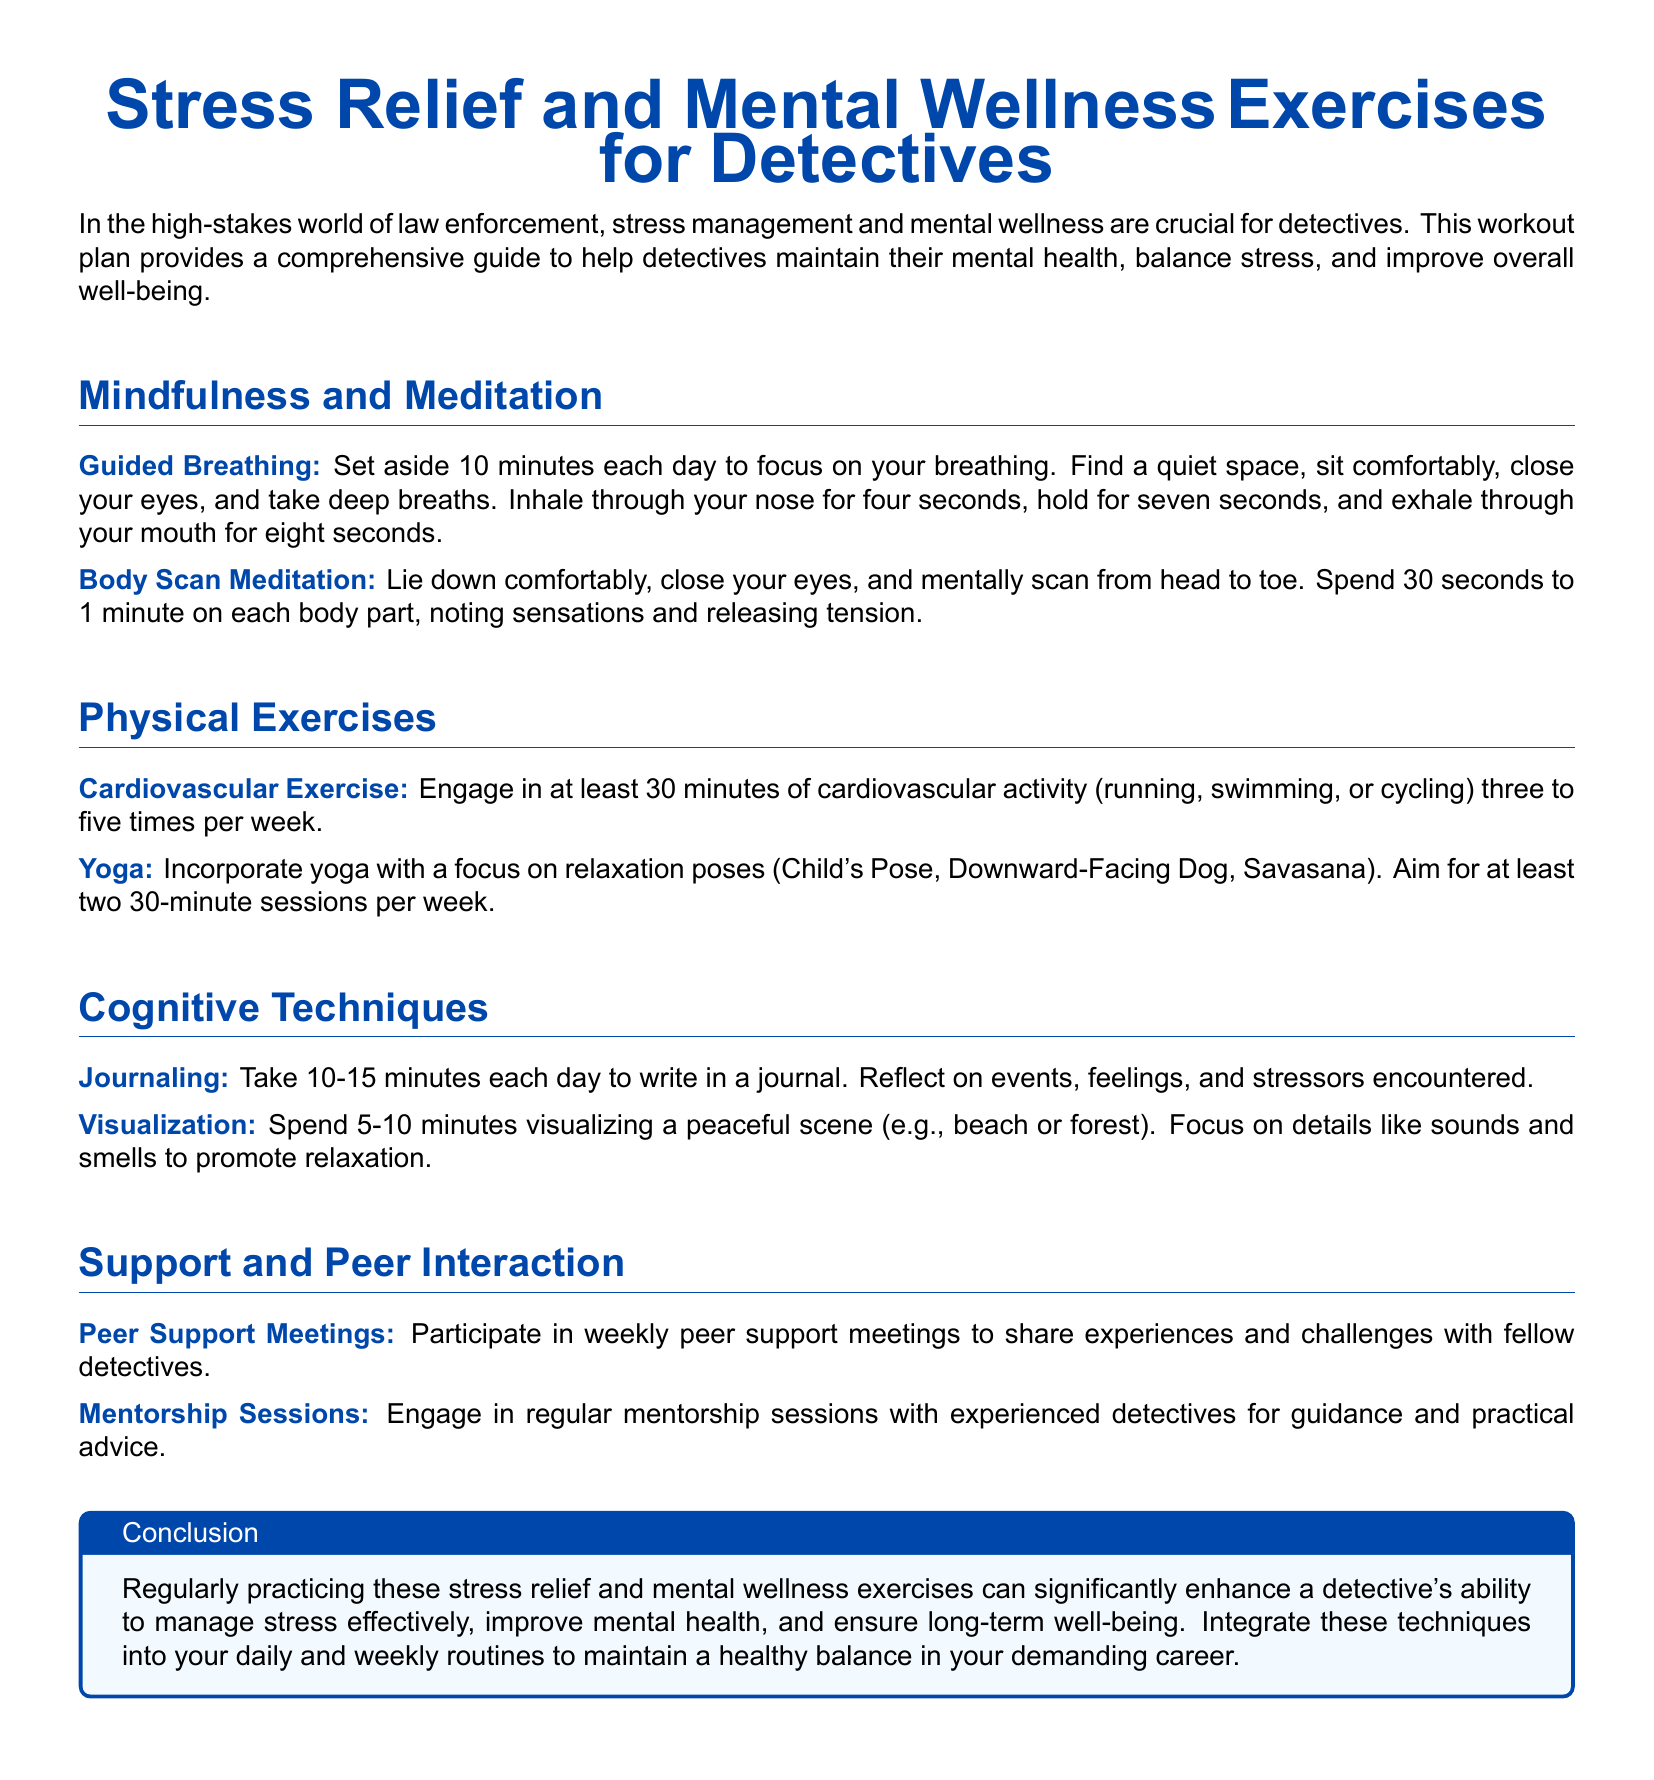What is the title of the document? The title of the document is prominently displayed at the beginning, which provides the focus of the content.
Answer: Stress Relief and Mental Wellness Exercises for Detectives How many minutes should the guided breathing exercise last? The document specifies a duration for the guided breathing exercise, emphasizing the importance of allocating dedicated time for this practice.
Answer: 10 minutes What type of exercise is recommended at least three to five times per week? The document lists specific physical activities that are encouraged for stress relief, with a clear recommendation on frequency.
Answer: Cardiovascular Exercise What activity should be included at least two times a week? This refers to a specific form of exercise aimed at promoting relaxation, as noted in the exercise section of the document.
Answer: Yoga How long should journaling be done each day? The document outlines a specific duration for this cognitive technique, aiming to provide a practical guideline for detectives.
Answer: 10-15 minutes What is the purpose of peer support meetings? The document outlines the benefit of these meetings, highlighting their relevance to the mental wellness of detectives.
Answer: Share experiences and challenges How often should mentorship sessions occur? The document encourages regular engagement with mentors, implying a frequency that supports ongoing professional development.
Answer: Regularly 